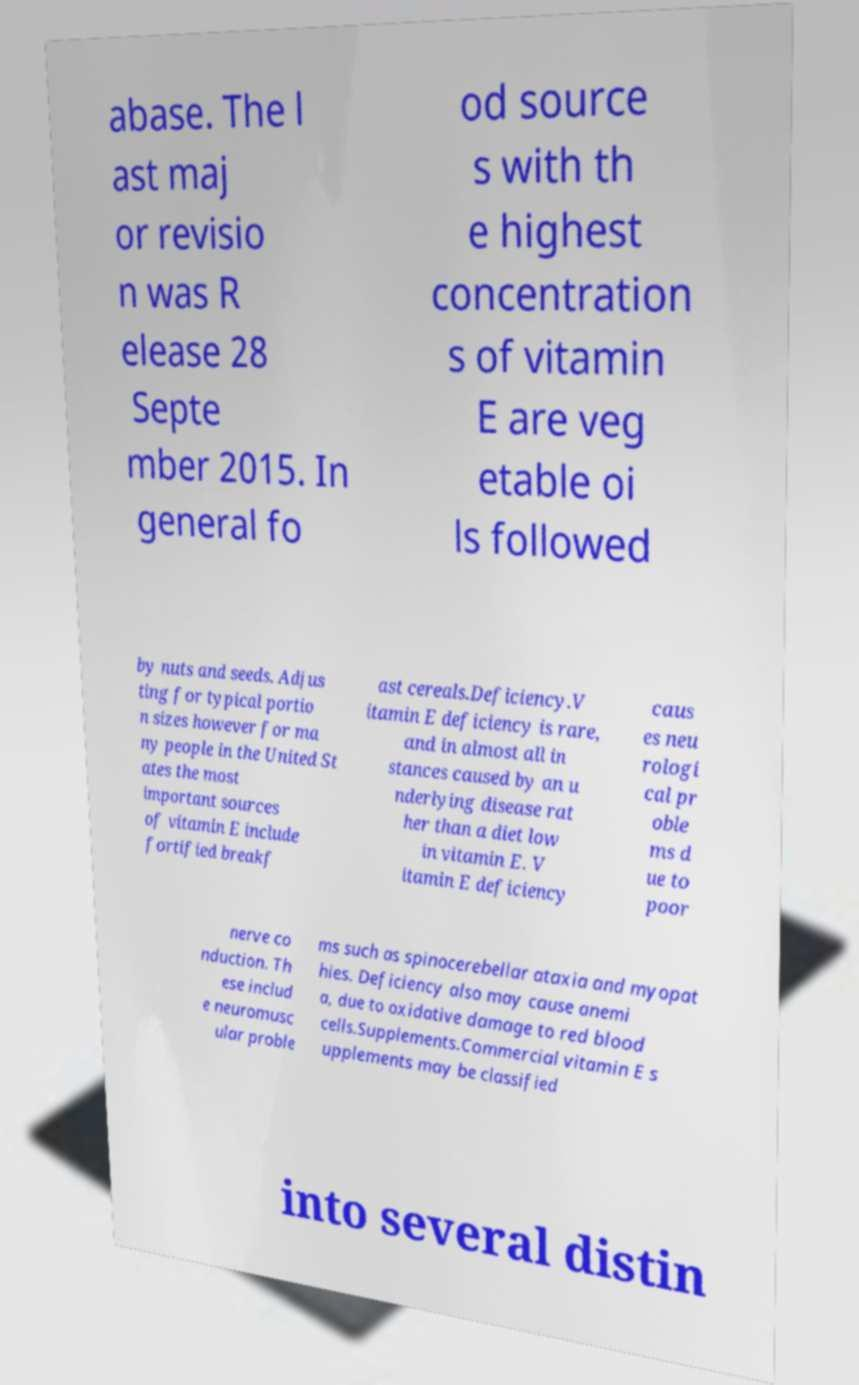Please identify and transcribe the text found in this image. abase. The l ast maj or revisio n was R elease 28 Septe mber 2015. In general fo od source s with th e highest concentration s of vitamin E are veg etable oi ls followed by nuts and seeds. Adjus ting for typical portio n sizes however for ma ny people in the United St ates the most important sources of vitamin E include fortified breakf ast cereals.Deficiency.V itamin E deficiency is rare, and in almost all in stances caused by an u nderlying disease rat her than a diet low in vitamin E. V itamin E deficiency caus es neu rologi cal pr oble ms d ue to poor nerve co nduction. Th ese includ e neuromusc ular proble ms such as spinocerebellar ataxia and myopat hies. Deficiency also may cause anemi a, due to oxidative damage to red blood cells.Supplements.Commercial vitamin E s upplements may be classified into several distin 